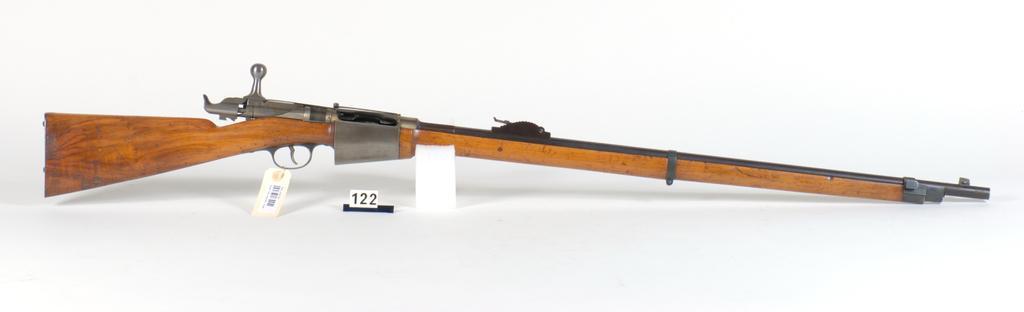Could you give a brief overview of what you see in this image? In this image there is a gun and there is a tag with a bar code. 